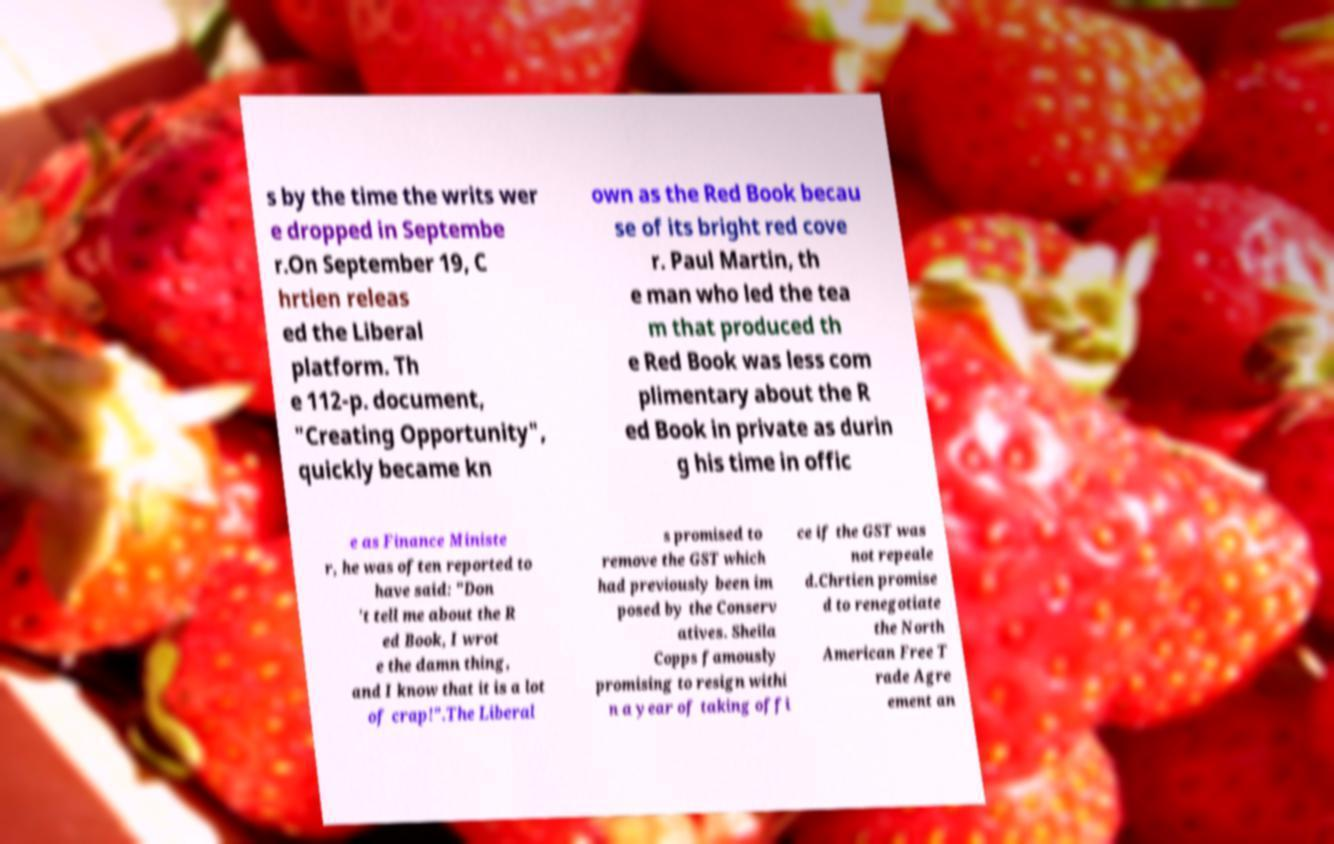Can you read and provide the text displayed in the image?This photo seems to have some interesting text. Can you extract and type it out for me? s by the time the writs wer e dropped in Septembe r.On September 19, C hrtien releas ed the Liberal platform. Th e 112-p. document, "Creating Opportunity", quickly became kn own as the Red Book becau se of its bright red cove r. Paul Martin, th e man who led the tea m that produced th e Red Book was less com plimentary about the R ed Book in private as durin g his time in offic e as Finance Ministe r, he was often reported to have said: "Don 't tell me about the R ed Book, I wrot e the damn thing, and I know that it is a lot of crap!".The Liberal s promised to remove the GST which had previously been im posed by the Conserv atives. Sheila Copps famously promising to resign withi n a year of taking offi ce if the GST was not repeale d.Chrtien promise d to renegotiate the North American Free T rade Agre ement an 